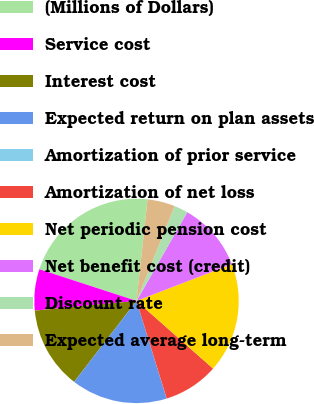Convert chart to OTSL. <chart><loc_0><loc_0><loc_500><loc_500><pie_chart><fcel>(Millions of Dollars)<fcel>Service cost<fcel>Interest cost<fcel>Expected return on plan assets<fcel>Amortization of prior service<fcel>Amortization of net loss<fcel>Net periodic pension cost<fcel>Net benefit cost (credit)<fcel>Discount rate<fcel>Expected average long-term<nl><fcel>21.71%<fcel>6.53%<fcel>13.04%<fcel>15.21%<fcel>0.02%<fcel>8.7%<fcel>17.38%<fcel>10.87%<fcel>2.19%<fcel>4.36%<nl></chart> 